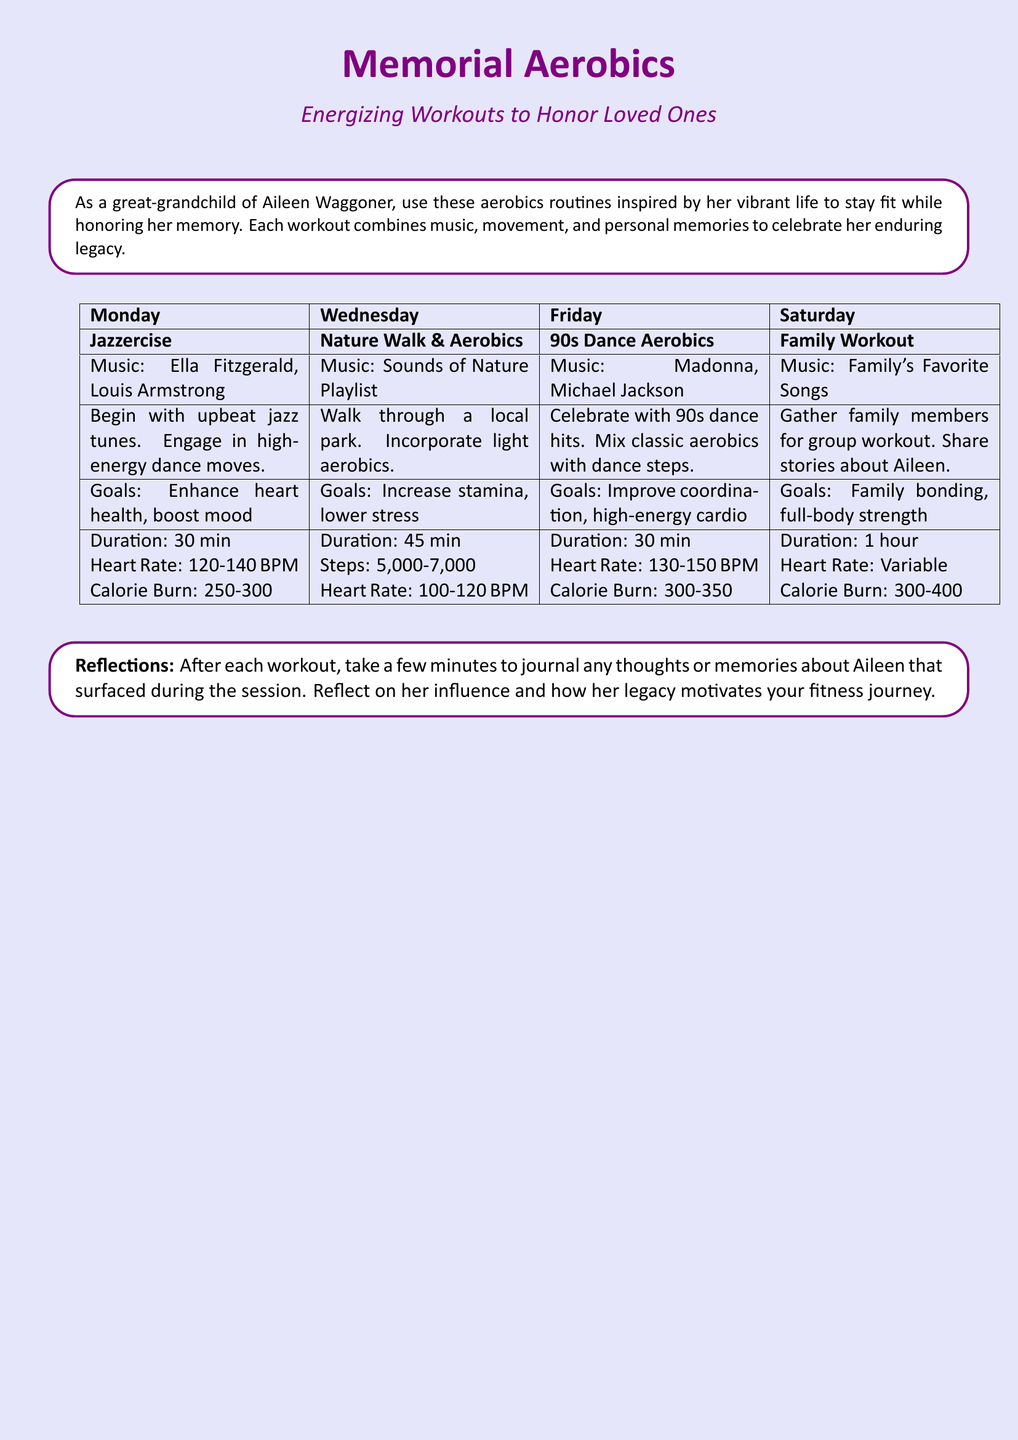What is the title of the document? The title is prominently displayed at the top of the document, which is "Memorial Aerobics".
Answer: Memorial Aerobics What day features Jazzercise? The workout plan includes Jazzercise on Monday.
Answer: Monday What is the music associated with Family Workout? The music for Family Workout is mentioned as "Family's Favorite Songs".
Answer: Family's Favorite Songs What is the goal of the Nature Walk & Aerobics? The goals for this workout include increasing stamina and lowering stress, as stated in the document.
Answer: Increase stamina, lower stress How long should the Saturday workout last? The duration listed for the Family Workout on Saturday is 1 hour.
Answer: 1 hour What is the calorie burn for the 90s Dance Aerobics? The document specifies the calorie burn for this workout as 300-350 calories.
Answer: 300-350 What should participants do after each workout? After each workout, participants are encouraged to journal any thoughts or memories about Aileen.
Answer: Journal thoughts or memories What is the heart rate target for Jazzercise? The heart rate target for Jazzercise is provided as 120-140 BPM.
Answer: 120-140 BPM What type of exercise is combined with music in this plan? The exercises in the plan combine aerobics with music inspired by Aileen's life.
Answer: Aerobics 